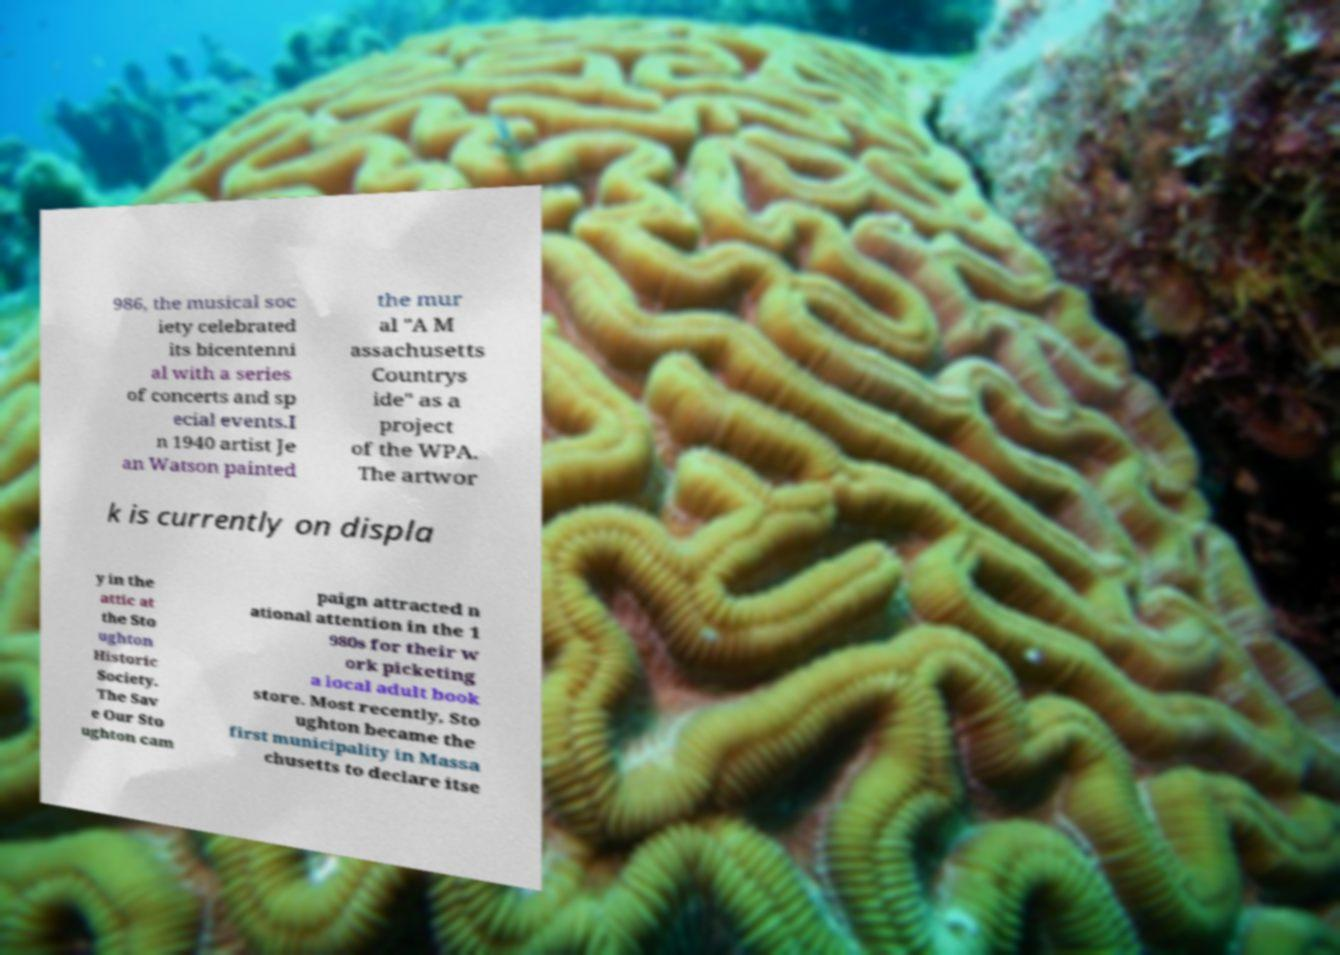There's text embedded in this image that I need extracted. Can you transcribe it verbatim? 986, the musical soc iety celebrated its bicentenni al with a series of concerts and sp ecial events.I n 1940 artist Je an Watson painted the mur al "A M assachusetts Countrys ide" as a project of the WPA. The artwor k is currently on displa y in the attic at the Sto ughton Historic Society. The Sav e Our Sto ughton cam paign attracted n ational attention in the 1 980s for their w ork picketing a local adult book store. Most recently, Sto ughton became the first municipality in Massa chusetts to declare itse 